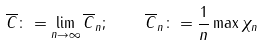Convert formula to latex. <formula><loc_0><loc_0><loc_500><loc_500>\overline { C } \colon = \lim _ { n \to \infty } \overline { C } _ { n } ; \quad \overline { C } _ { n } \colon = \frac { 1 } { n } \max \chi _ { n }</formula> 